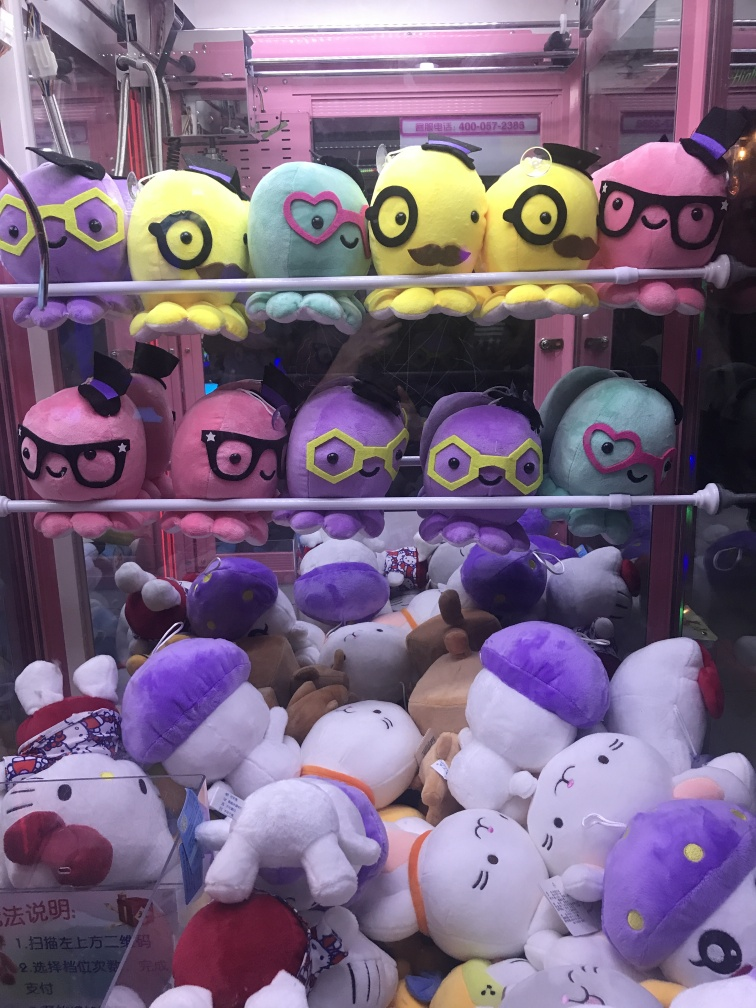What does this image suggest about the setting or location? The image implies that we're looking at a row of claw machines, likely situated in an arcade, amusement park, or a similar recreational space. The presence of such machines is often associated with entertainment venues where games and prizes are a factor of the experience. Furthermore, the assortment of plush toys, along with the written characters visible on the machine's signage, suggest the location might be in an East Asian country, potentially a place with a high interest in pop culture and cute merchandise. 